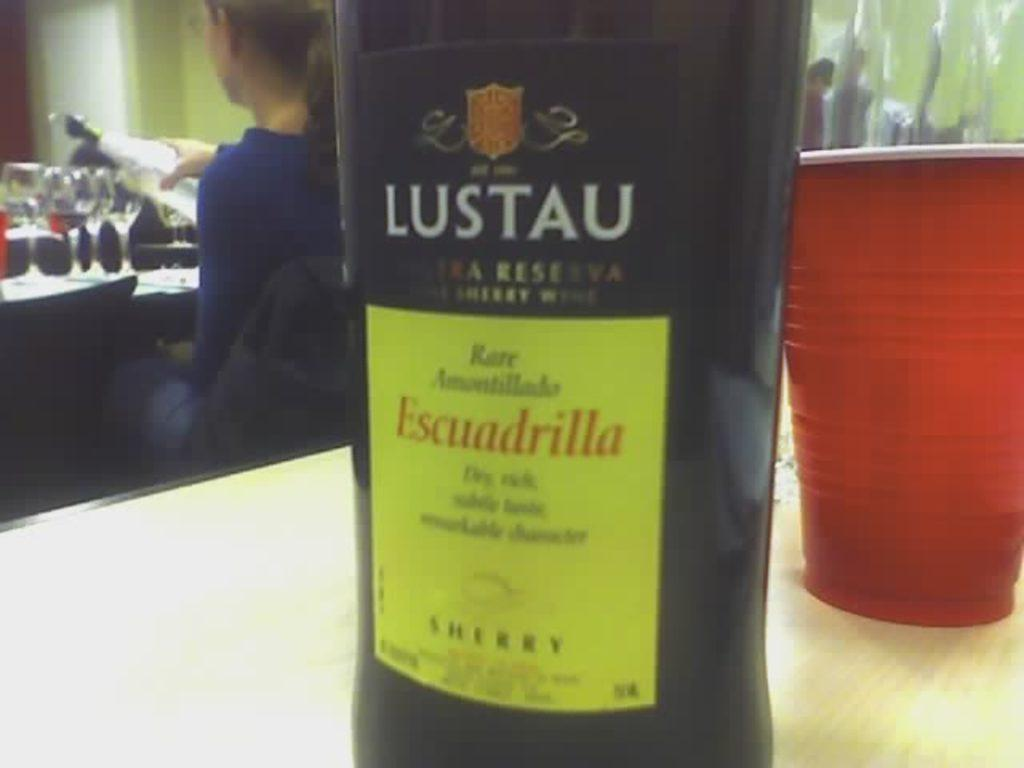What object can be seen in the image? There is a bottle in the image. What other object is present on the table in the image? There is a cup on the table in the image. Can you describe the woman in the image? There is a woman sitting at the back of the image, and she is holding a bottle. How many people are in the image? There is another person in the image besides the woman. What type of design can be seen on the fog in the image? There is no fog present in the image, so it is not possible to answer that question. 